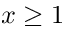<formula> <loc_0><loc_0><loc_500><loc_500>x \geq 1</formula> 